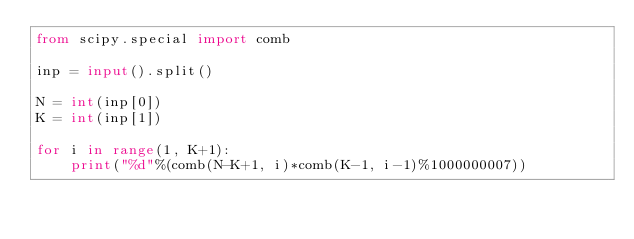<code> <loc_0><loc_0><loc_500><loc_500><_Python_>from scipy.special import comb

inp = input().split()

N = int(inp[0])
K = int(inp[1])

for i in range(1, K+1):
    print("%d"%(comb(N-K+1, i)*comb(K-1, i-1)%1000000007))</code> 